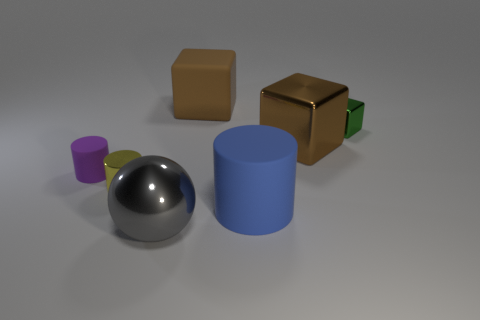What shape is the tiny thing that is on the right side of the brown thing that is in front of the block to the right of the large brown metallic thing?
Provide a short and direct response. Cube. The large brown matte thing has what shape?
Give a very brief answer. Cube. The matte thing that is in front of the purple object is what color?
Your answer should be very brief. Blue. Does the brown metallic thing that is behind the blue matte thing have the same size as the large gray ball?
Provide a succinct answer. Yes. There is a green metal thing that is the same shape as the large brown metal object; what size is it?
Keep it short and to the point. Small. Is there any other thing that is the same size as the rubber block?
Make the answer very short. Yes. Do the blue thing and the small purple object have the same shape?
Give a very brief answer. Yes. Are there fewer big shiny objects behind the gray thing than big brown cubes that are to the left of the tiny yellow cylinder?
Offer a terse response. No. There is a brown rubber cube; how many big rubber things are in front of it?
Your answer should be very brief. 1. There is a big rubber object that is in front of the small block; is its shape the same as the small shiny thing left of the brown rubber cube?
Your answer should be compact. Yes. 